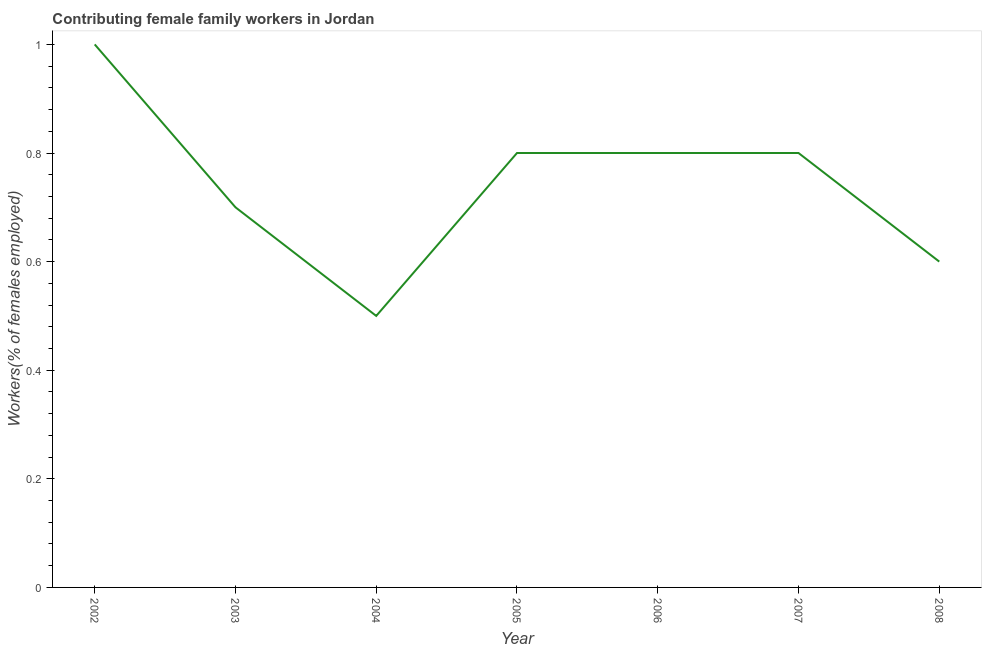What is the contributing female family workers in 2008?
Give a very brief answer. 0.6. What is the sum of the contributing female family workers?
Offer a very short reply. 5.2. What is the difference between the contributing female family workers in 2003 and 2008?
Offer a very short reply. 0.1. What is the average contributing female family workers per year?
Your answer should be compact. 0.74. What is the median contributing female family workers?
Offer a terse response. 0.8. In how many years, is the contributing female family workers greater than 0.2 %?
Give a very brief answer. 7. Do a majority of the years between 2002 and 2007 (inclusive) have contributing female family workers greater than 0.36 %?
Make the answer very short. Yes. What is the ratio of the contributing female family workers in 2007 to that in 2008?
Your answer should be very brief. 1.33. Is the difference between the contributing female family workers in 2002 and 2004 greater than the difference between any two years?
Give a very brief answer. Yes. What is the difference between the highest and the second highest contributing female family workers?
Provide a succinct answer. 0.2. In how many years, is the contributing female family workers greater than the average contributing female family workers taken over all years?
Your response must be concise. 4. Does the contributing female family workers monotonically increase over the years?
Provide a succinct answer. No. Does the graph contain any zero values?
Provide a succinct answer. No. What is the title of the graph?
Ensure brevity in your answer.  Contributing female family workers in Jordan. What is the label or title of the X-axis?
Make the answer very short. Year. What is the label or title of the Y-axis?
Provide a short and direct response. Workers(% of females employed). What is the Workers(% of females employed) of 2002?
Offer a very short reply. 1. What is the Workers(% of females employed) of 2003?
Give a very brief answer. 0.7. What is the Workers(% of females employed) in 2004?
Provide a succinct answer. 0.5. What is the Workers(% of females employed) of 2005?
Make the answer very short. 0.8. What is the Workers(% of females employed) in 2006?
Make the answer very short. 0.8. What is the Workers(% of females employed) of 2007?
Make the answer very short. 0.8. What is the Workers(% of females employed) in 2008?
Ensure brevity in your answer.  0.6. What is the difference between the Workers(% of females employed) in 2002 and 2003?
Your answer should be very brief. 0.3. What is the difference between the Workers(% of females employed) in 2002 and 2004?
Provide a short and direct response. 0.5. What is the difference between the Workers(% of females employed) in 2002 and 2005?
Offer a terse response. 0.2. What is the difference between the Workers(% of females employed) in 2003 and 2004?
Your answer should be very brief. 0.2. What is the difference between the Workers(% of females employed) in 2003 and 2007?
Your response must be concise. -0.1. What is the difference between the Workers(% of females employed) in 2003 and 2008?
Offer a terse response. 0.1. What is the difference between the Workers(% of females employed) in 2004 and 2005?
Offer a very short reply. -0.3. What is the difference between the Workers(% of females employed) in 2004 and 2006?
Offer a very short reply. -0.3. What is the difference between the Workers(% of females employed) in 2004 and 2007?
Give a very brief answer. -0.3. What is the difference between the Workers(% of females employed) in 2005 and 2008?
Ensure brevity in your answer.  0.2. What is the difference between the Workers(% of females employed) in 2006 and 2007?
Provide a succinct answer. 0. What is the difference between the Workers(% of females employed) in 2006 and 2008?
Give a very brief answer. 0.2. What is the ratio of the Workers(% of females employed) in 2002 to that in 2003?
Give a very brief answer. 1.43. What is the ratio of the Workers(% of females employed) in 2002 to that in 2008?
Give a very brief answer. 1.67. What is the ratio of the Workers(% of females employed) in 2003 to that in 2004?
Your answer should be very brief. 1.4. What is the ratio of the Workers(% of females employed) in 2003 to that in 2005?
Offer a terse response. 0.88. What is the ratio of the Workers(% of females employed) in 2003 to that in 2006?
Keep it short and to the point. 0.88. What is the ratio of the Workers(% of females employed) in 2003 to that in 2007?
Ensure brevity in your answer.  0.88. What is the ratio of the Workers(% of females employed) in 2003 to that in 2008?
Provide a succinct answer. 1.17. What is the ratio of the Workers(% of females employed) in 2004 to that in 2006?
Provide a short and direct response. 0.62. What is the ratio of the Workers(% of females employed) in 2004 to that in 2008?
Your response must be concise. 0.83. What is the ratio of the Workers(% of females employed) in 2005 to that in 2008?
Make the answer very short. 1.33. What is the ratio of the Workers(% of females employed) in 2006 to that in 2007?
Ensure brevity in your answer.  1. What is the ratio of the Workers(% of females employed) in 2006 to that in 2008?
Your response must be concise. 1.33. What is the ratio of the Workers(% of females employed) in 2007 to that in 2008?
Your answer should be compact. 1.33. 